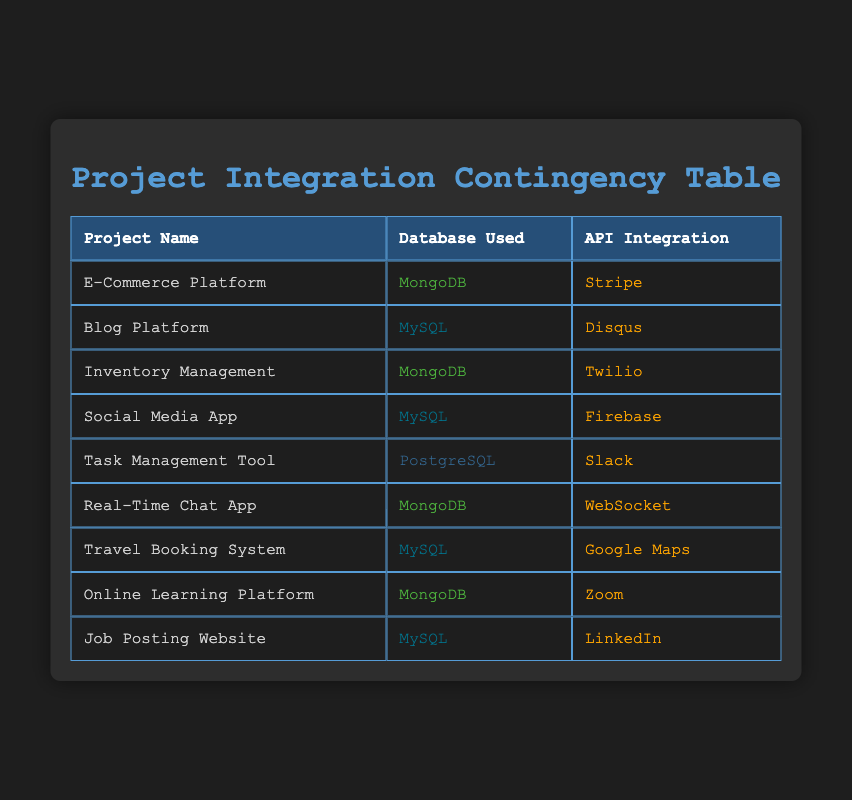What database is used by the Inventory Management project? The table lists the database used for each project in the second column. For the Inventory Management project, the corresponding entry in the database used column is MongoDB.
Answer: MongoDB How many projects used MySQL as the database? To determine the number of projects using MySQL, I count the occurrences of 'MySQL' in the database used column. There are four projects that use MySQL: Blog Platform, Social Media App, Travel Booking System, and Job Posting Website.
Answer: 4 Is there a project that uses both MongoDB and Stripe? I check the table to find if the combination of MongoDB and Stripe exists. The E-Commerce Platform uses MongoDB, but its API integration is Stripe. However, since we are looking for an exact match of both, the answer is no.
Answer: No What is the total number of projects listed in the table? I can count the number of rows in the table under the projects section. There are a total of nine projects listed in the table.
Answer: 9 Which API integration is used the most among the listed projects? I need to list all API integrations found in the table and count their occurrences. The API integrations are: Stripe (1), Disqus (1), Twilio (1), Firebase (1), Slack (1), WebSocket (1), Google Maps (1), Zoom (1), and LinkedIn (1). Each integration is used only once. Therefore, there is no single most used API integration.
Answer: All are used once 